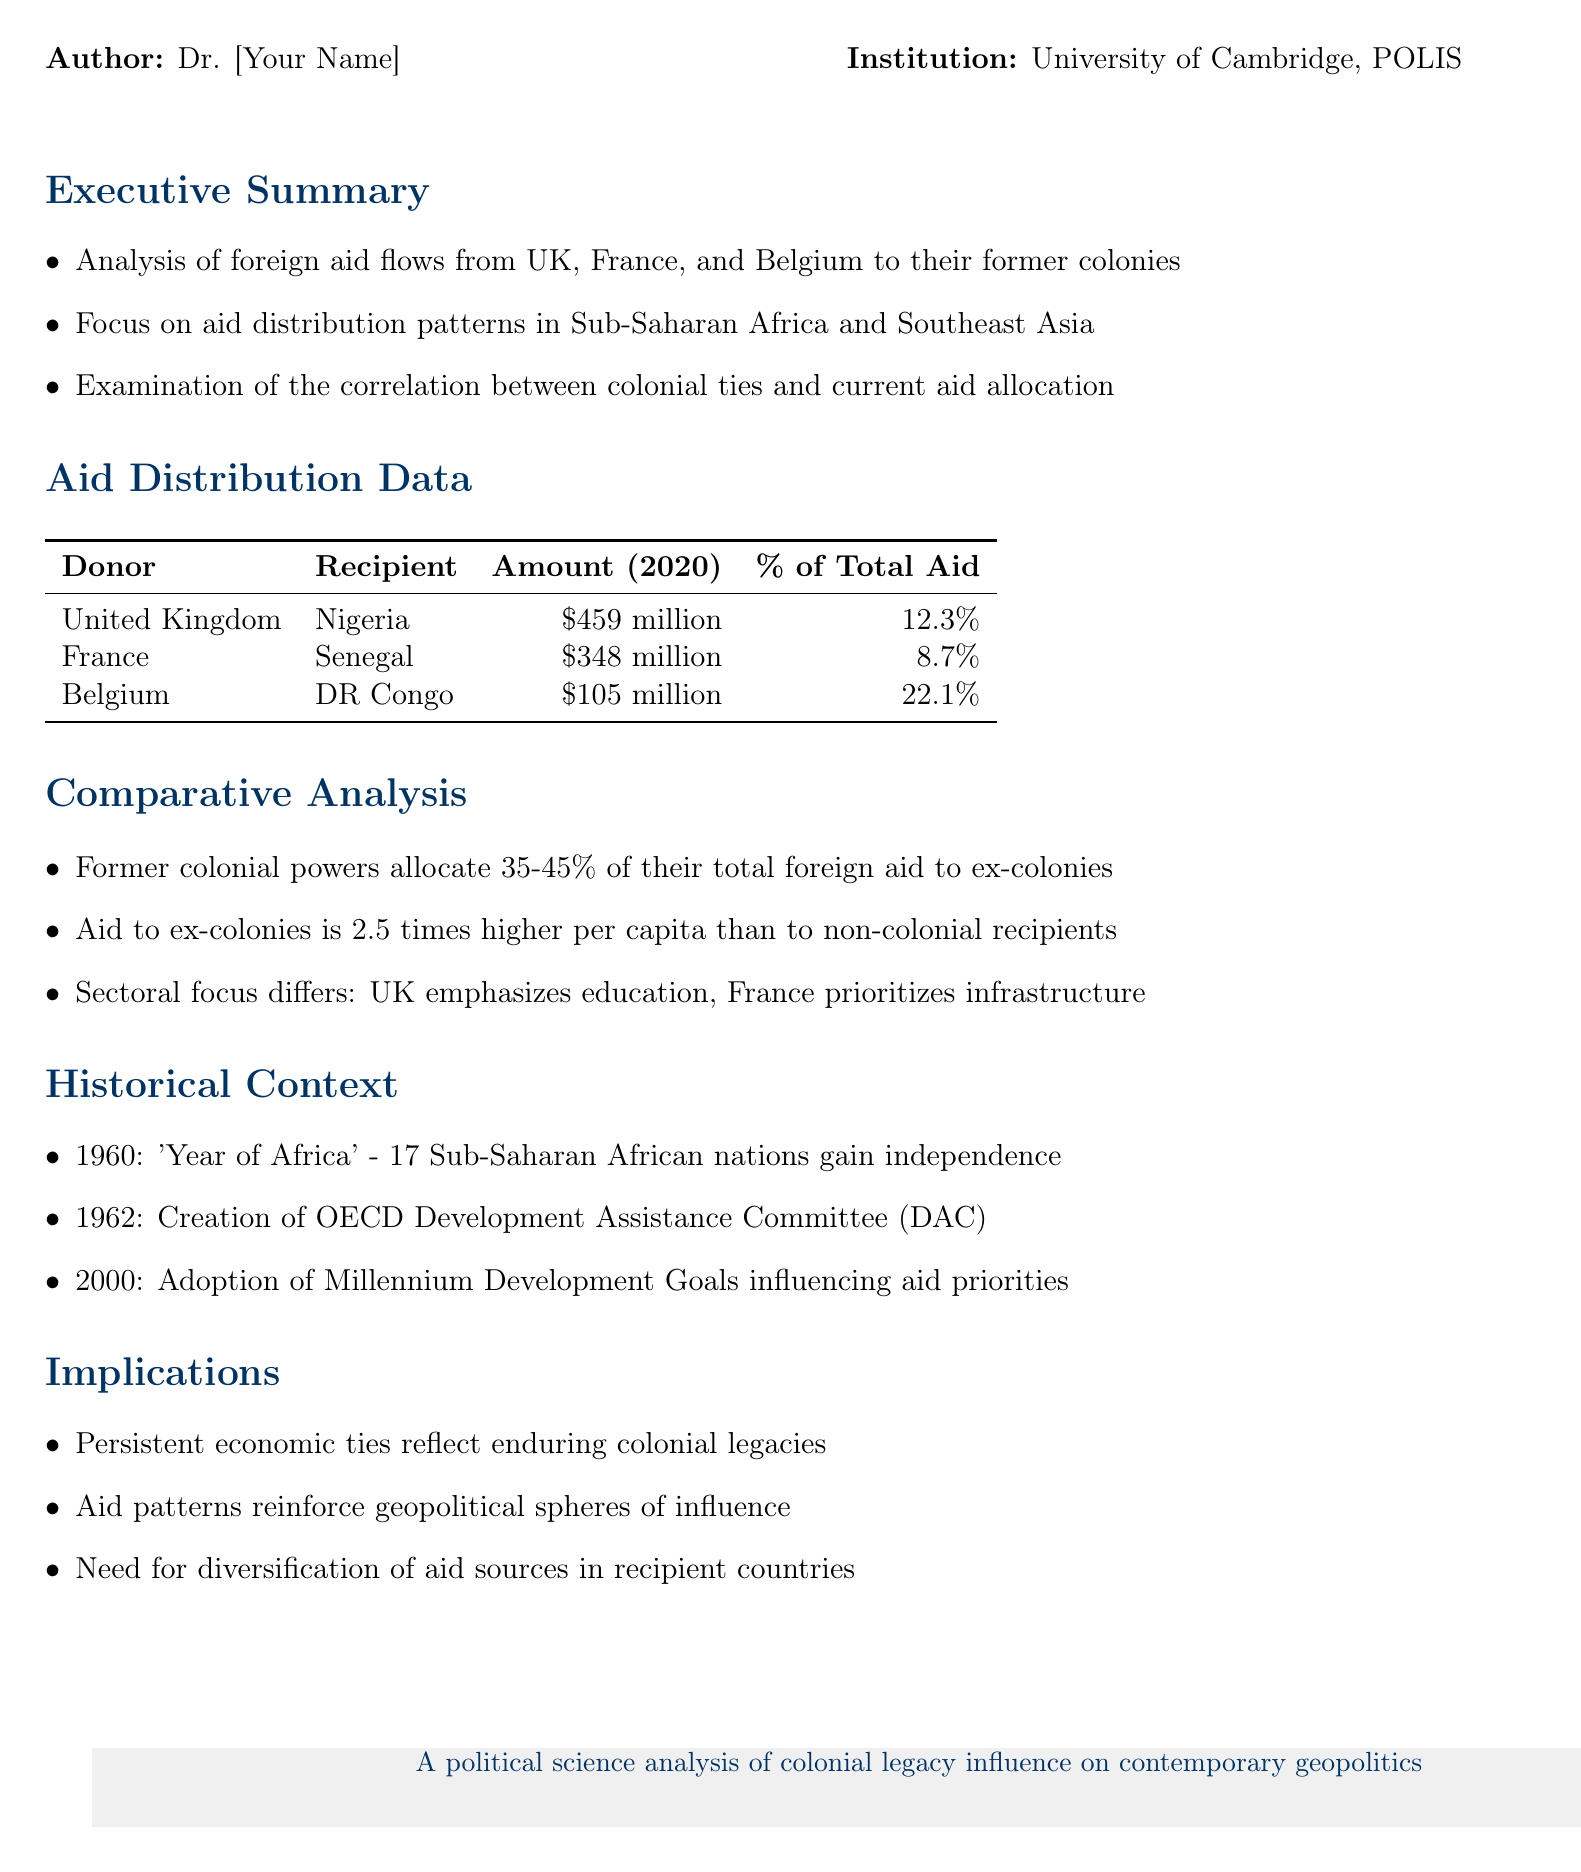What is the total aid amount from the UK to Nigeria? The total aid amount is explicitly stated in the document as $459 million.
Answer: $459 million What percentage of total aid does France allocate to Senegal? The document specifies that France allocates 8.7% of its total aid to Senegal.
Answer: 8.7% What is the sectoral focus of the UK in foreign aid? The document mentions that the UK's sectoral focus emphasizes education.
Answer: Education What is the per capita aid amount difference between ex-colonies and non-colonial recipients? The analysis states that aid to ex-colonies is 2.5 times higher per capita than to non-colonial recipients.
Answer: 2.5 times higher Which former colonial power allocated the most aid to their ex-colony in the document? The document shows that the UK allocated the highest amount of aid to Nigeria at $459 million.
Answer: United Kingdom Which year is referred to as the 'Year of Africa'? The historical context in the document notes that the year 1960 is referred to as the 'Year of Africa'.
Answer: 1960 What are the implications of persistent economic ties according to the document? The document indicates that persistent economic ties reflect enduring colonial legacies.
Answer: Enduring colonial legacies What is the main focus of France in aid distribution? The document highlights that France prioritizes infrastructure in its aid distribution.
Answer: Infrastructure 